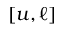<formula> <loc_0><loc_0><loc_500><loc_500>[ u , \ell ]</formula> 